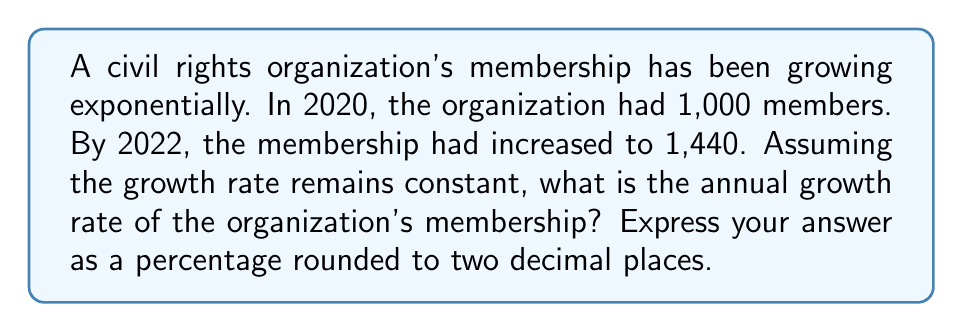Can you solve this math problem? Let's approach this step-by-step using the exponential growth formula:

$$A = P(1 + r)^t$$

Where:
$A$ = Final amount
$P$ = Initial amount
$r$ = Annual growth rate (in decimal form)
$t$ = Time in years

We know:
$P = 1,000$ (initial membership in 2020)
$A = 1,440$ (membership in 2022)
$t = 2$ (2 years from 2020 to 2022)

Let's plug these into our formula:

$$1,440 = 1,000(1 + r)^2$$

Now, let's solve for $r$:

1) Divide both sides by 1,000:
   $$1.44 = (1 + r)^2$$

2) Take the square root of both sides:
   $$\sqrt{1.44} = 1 + r$$

3) Simplify:
   $$1.2 = 1 + r$$

4) Subtract 1 from both sides:
   $$0.2 = r$$

5) Convert to a percentage:
   $$r = 0.2 * 100\% = 20\%$$

Therefore, the annual growth rate is 20%.
Answer: 20.00% 